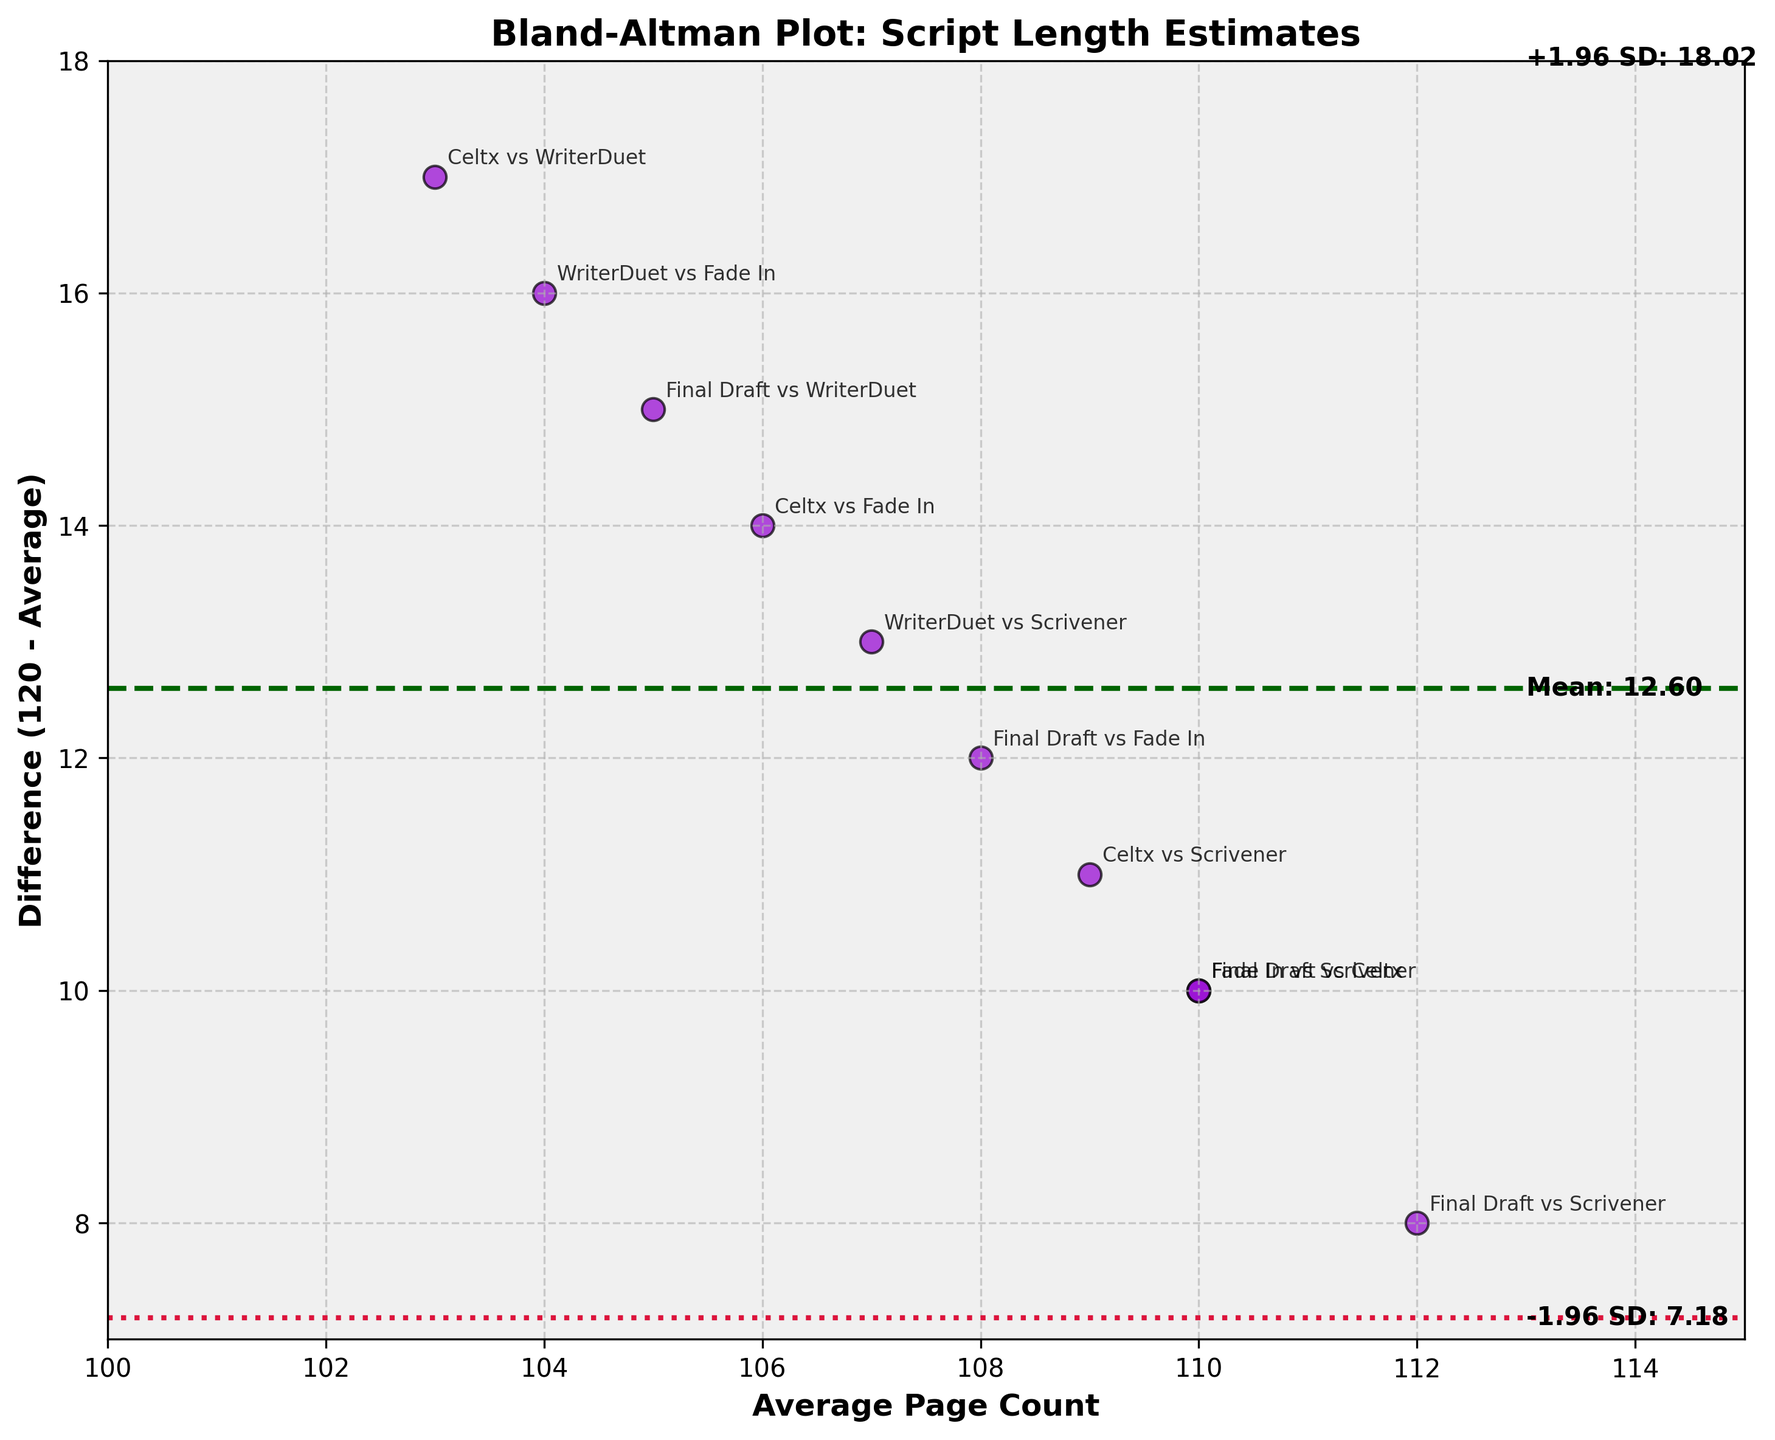What's the title of the plot? The title of the plot is located at the top of the chart, written in bold as “Bland-Altman Plot: Script Length Estimates."
Answer: Bland-Altman Plot: Script Length Estimates How many data points are plotted on the graph? Each data point represents a comparison between two software tools, and there are a total of 10 such comparisons.
Answer: 10 What is the mean difference line value? The mean difference line is represented in dark green and labeled as "Mean: -5.50" on the right side of the plot.
Answer: -5.50 Which software pair has the smallest difference and what is it? The smallest difference is identified by the vertical position closest to zero on the Y-axis. "WriterDuet vs Fade In" is closest to zero with a difference of 16.
Answer: WriterDuet vs Fade In, 16 What are the limits of agreement? The plot has two crimson dashed lines indicating the limits of agreement, labeled "+1.96 SD: 0.88" and "-1.96 SD: -11.88" on the right side of the plot.
Answer: -11.88 and 0.88 What is the average page count of the software pair with the largest difference? Locate the data point with the largest vertical deviation from the mean difference line. "Final Draft vs Celtx" has the largest difference of 10, with an average page count of 110.
Answer: 110 Are there any software pairs with differences outside the limits of agreement? Check if any data points fall outside the crimson dashed lines indicating the limits of agreement. No data points fall outside these lines.
Answer: No Between which software pairs do we observe the difference closest to the mean difference line? The mean difference line intersects the Y-axis at -5.50. The software pairs that are closest to this value are "WriterDuet vs Scrivener" and "Celtx vs Fade In," with differences around -16 and -14, respectively.
Answer: WriterDuet vs Scrivener and Celtx vs Fade In How many software pairs have a positive difference from the mean? Count the data points that are above the mean difference line at -5.50. There are three such data points.
Answer: 3 